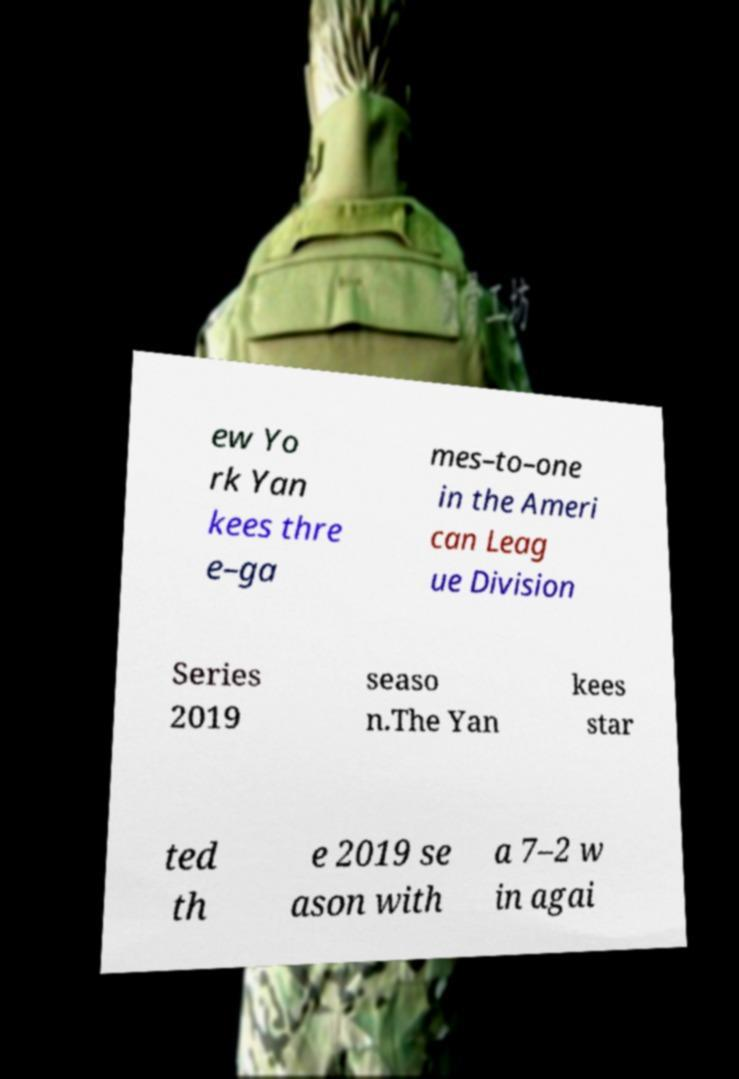Could you assist in decoding the text presented in this image and type it out clearly? ew Yo rk Yan kees thre e–ga mes–to–one in the Ameri can Leag ue Division Series 2019 seaso n.The Yan kees star ted th e 2019 se ason with a 7–2 w in agai 